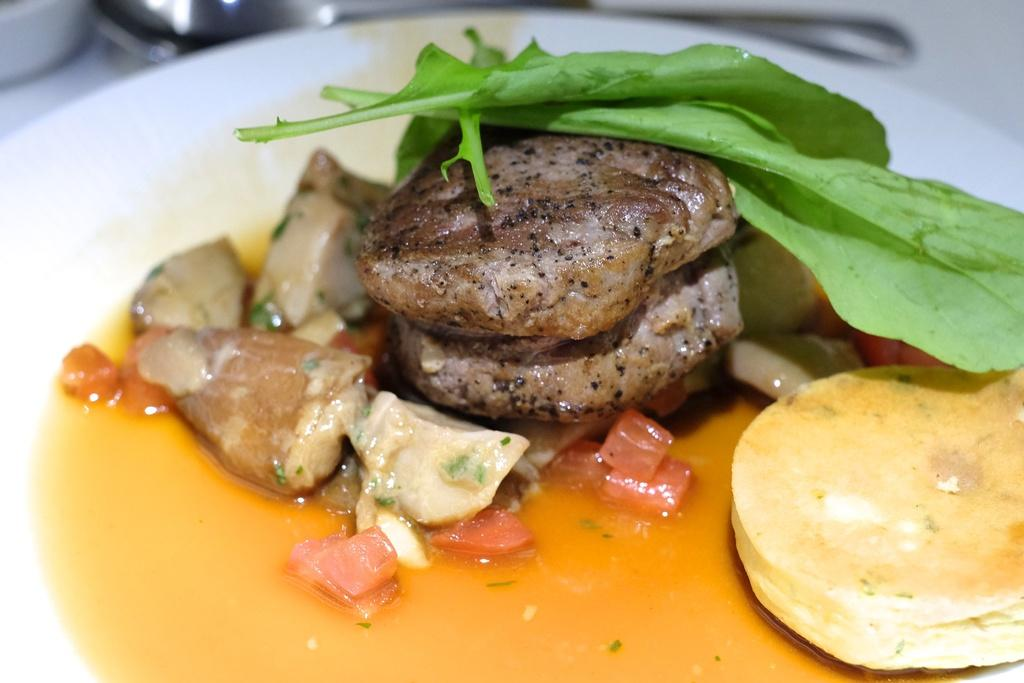What is on the plate in the image? There is food on a plate in the image. How many rings are visible on the person's haircut in the image? There is no person or haircut present in the image; it only features a plate of food. 